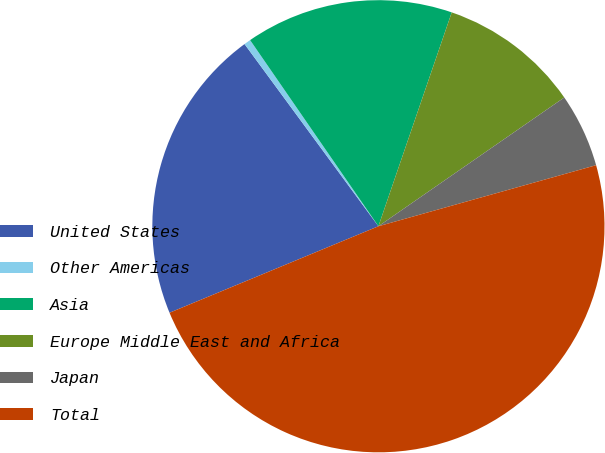Convert chart to OTSL. <chart><loc_0><loc_0><loc_500><loc_500><pie_chart><fcel>United States<fcel>Other Americas<fcel>Asia<fcel>Europe Middle East and Africa<fcel>Japan<fcel>Total<nl><fcel>21.16%<fcel>0.48%<fcel>14.86%<fcel>10.1%<fcel>5.29%<fcel>48.1%<nl></chart> 